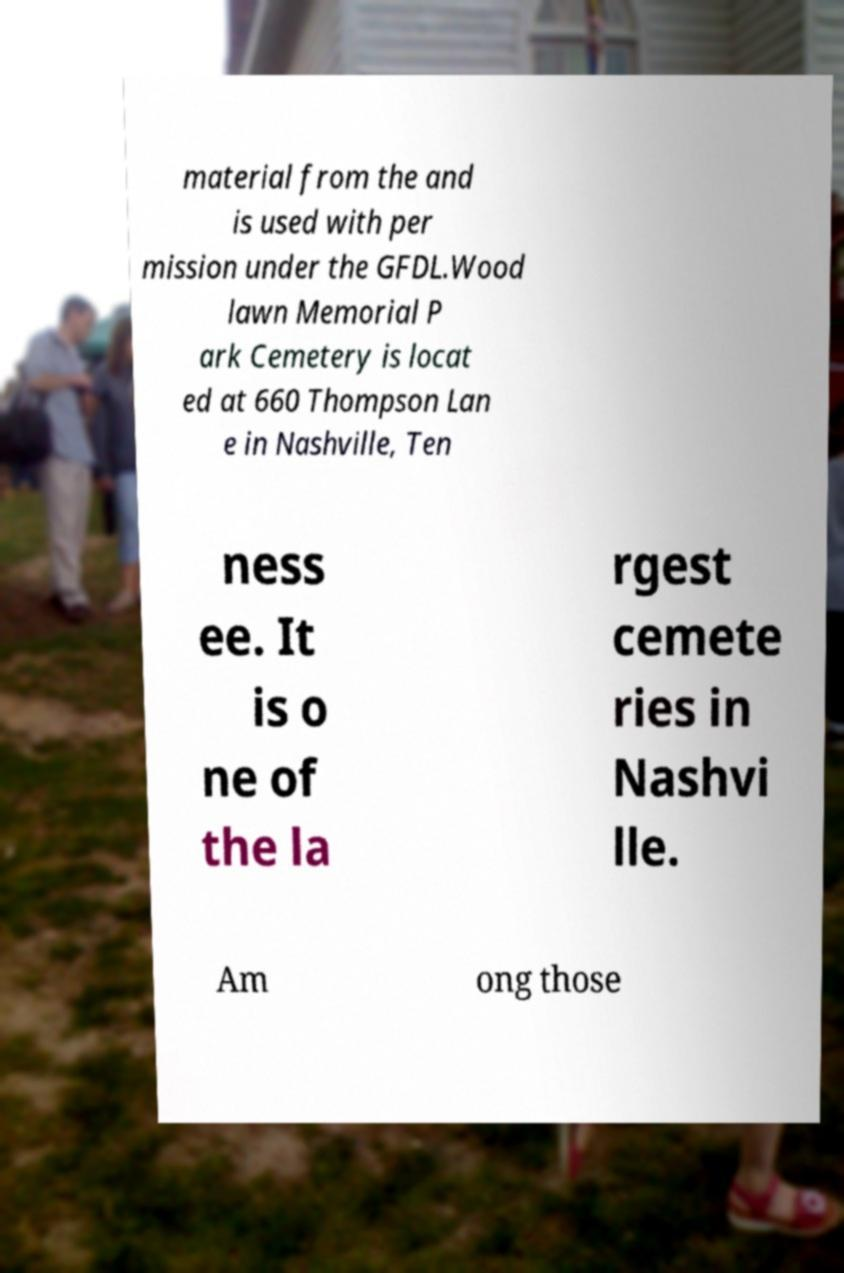Could you assist in decoding the text presented in this image and type it out clearly? material from the and is used with per mission under the GFDL.Wood lawn Memorial P ark Cemetery is locat ed at 660 Thompson Lan e in Nashville, Ten ness ee. It is o ne of the la rgest cemete ries in Nashvi lle. Am ong those 